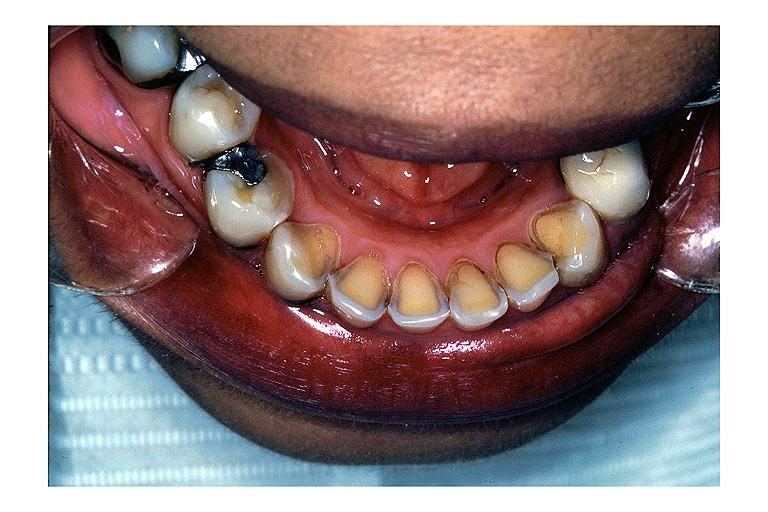what does this image show?
Answer the question using a single word or phrase. Erosion 